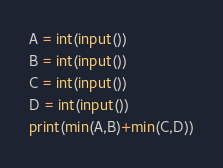Convert code to text. <code><loc_0><loc_0><loc_500><loc_500><_Python_>A = int(input())
B = int(input())
C = int(input())
D = int(input())
print(min(A,B)+min(C,D))</code> 